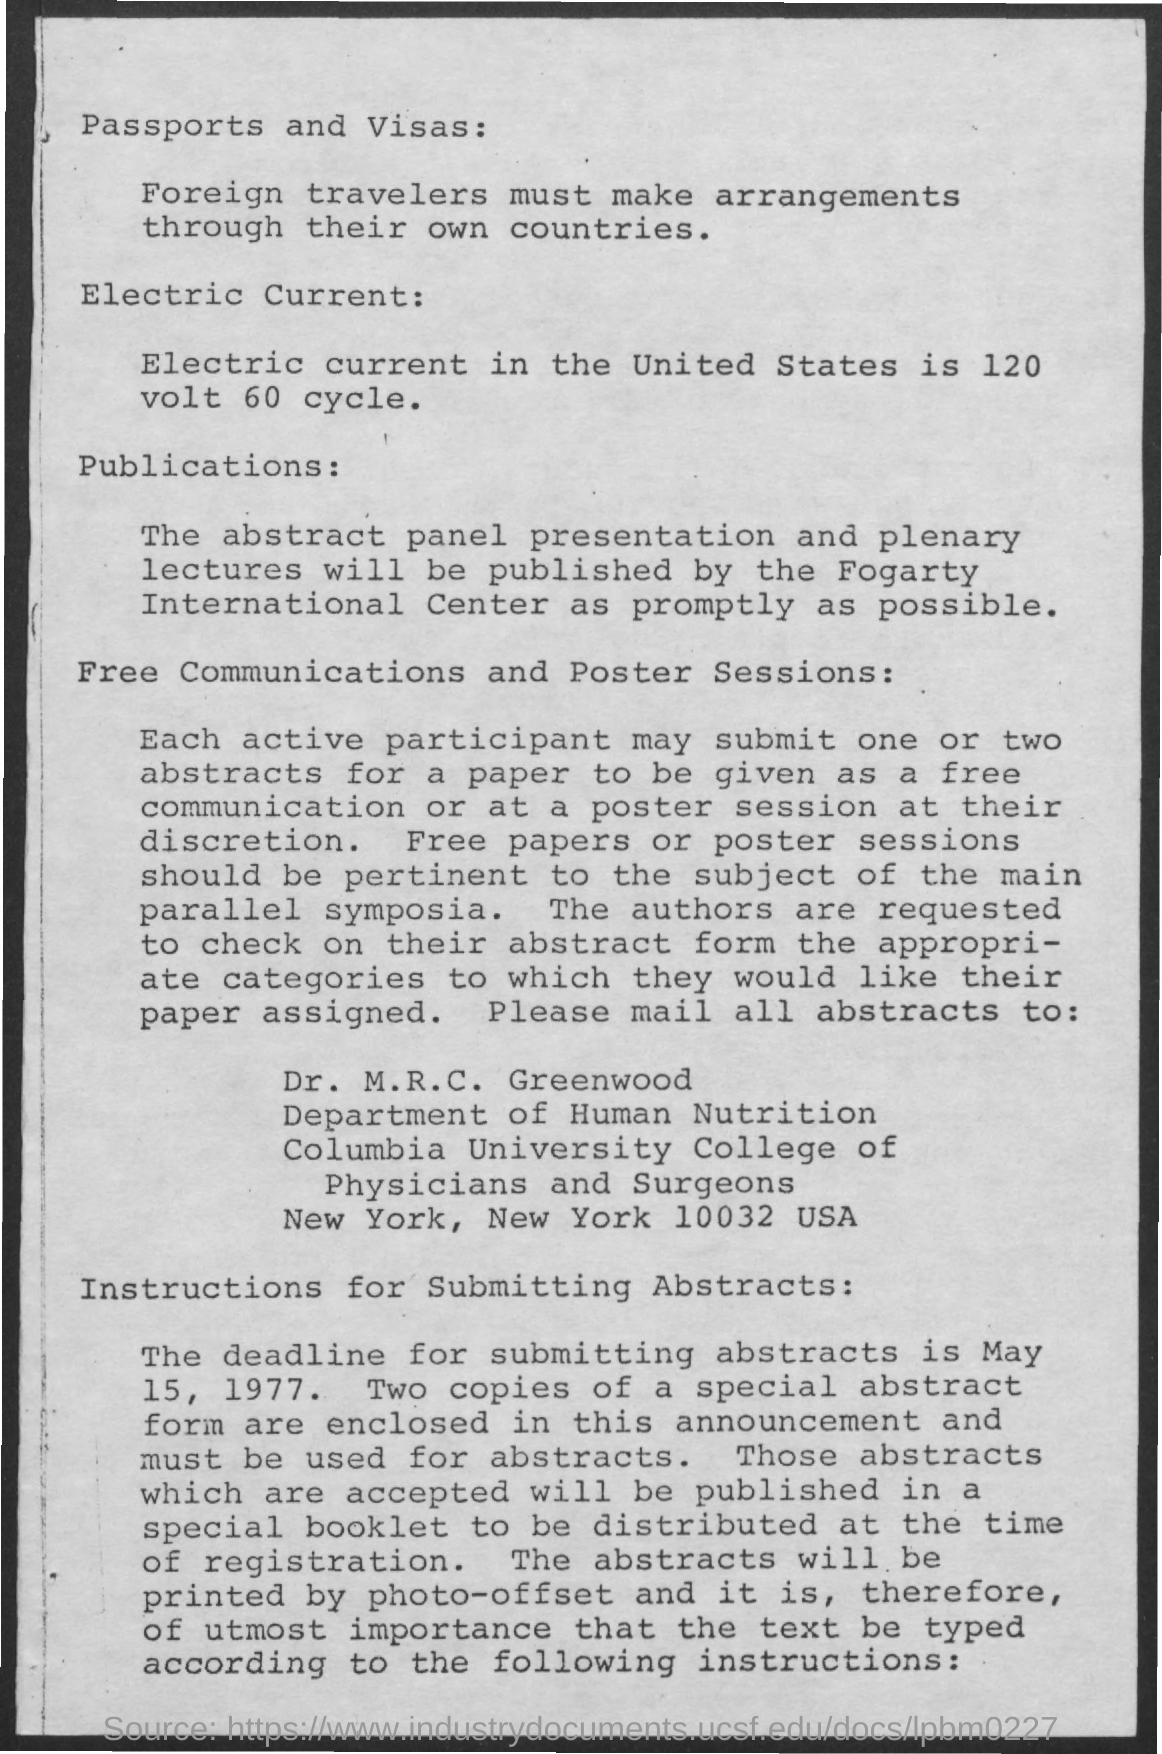Indicate a few pertinent items in this graphic. The individual to whom all abstracts should be mailed is Dr. M. R. C. Greenwood. The electric current in the United States is 120 volts and 60 cycles. The Fogarty International Center will publish the abstract panel presentations and plenary lectures. The deadline for submitting abstracts is May 15, 1977. 